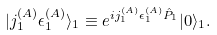<formula> <loc_0><loc_0><loc_500><loc_500>| j ^ { ( A ) } _ { 1 } \epsilon ^ { ( A ) } _ { 1 } \rangle _ { 1 } \equiv e ^ { i j ^ { ( A ) } _ { 1 } \epsilon ^ { ( A ) } _ { 1 } { \hat { P } } _ { 1 } } | 0 \rangle _ { 1 } .</formula> 